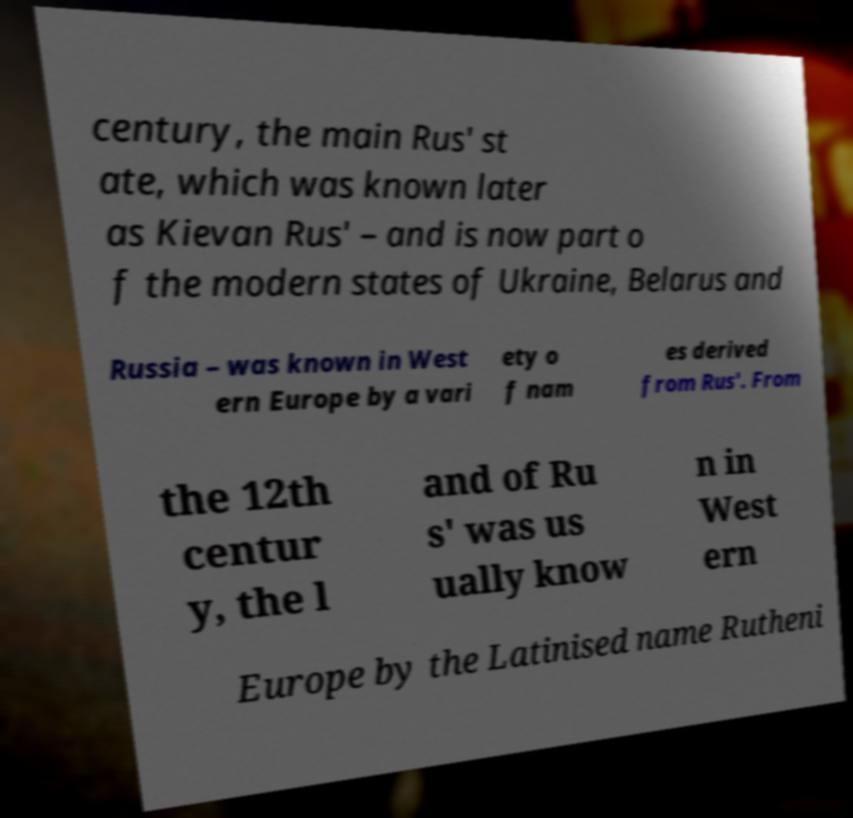Could you assist in decoding the text presented in this image and type it out clearly? century, the main Rus' st ate, which was known later as Kievan Rus' – and is now part o f the modern states of Ukraine, Belarus and Russia – was known in West ern Europe by a vari ety o f nam es derived from Rus'. From the 12th centur y, the l and of Ru s' was us ually know n in West ern Europe by the Latinised name Rutheni 